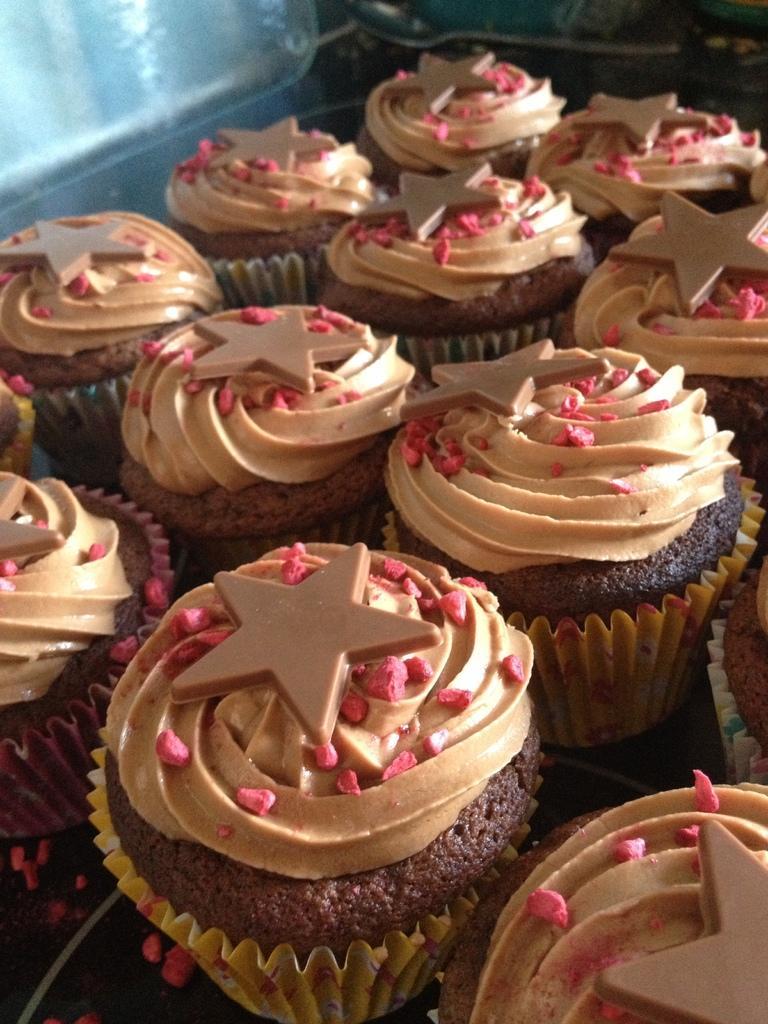How would you summarize this image in a sentence or two? In this picture we can see cup cakes on a surface and in the background we can see a spoon and some objects. 